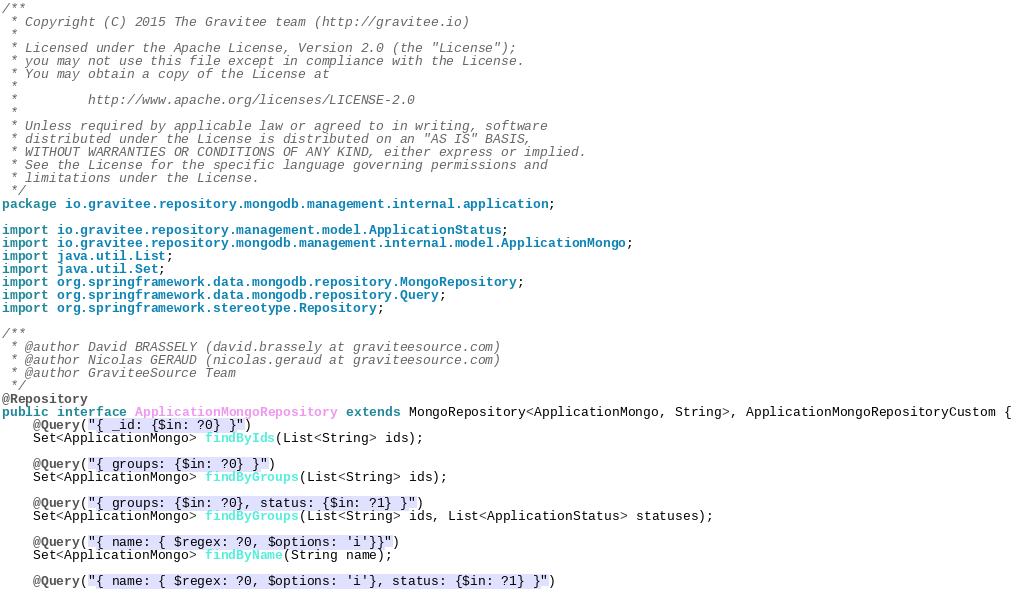Convert code to text. <code><loc_0><loc_0><loc_500><loc_500><_Java_>/**
 * Copyright (C) 2015 The Gravitee team (http://gravitee.io)
 *
 * Licensed under the Apache License, Version 2.0 (the "License");
 * you may not use this file except in compliance with the License.
 * You may obtain a copy of the License at
 *
 *         http://www.apache.org/licenses/LICENSE-2.0
 *
 * Unless required by applicable law or agreed to in writing, software
 * distributed under the License is distributed on an "AS IS" BASIS,
 * WITHOUT WARRANTIES OR CONDITIONS OF ANY KIND, either express or implied.
 * See the License for the specific language governing permissions and
 * limitations under the License.
 */
package io.gravitee.repository.mongodb.management.internal.application;

import io.gravitee.repository.management.model.ApplicationStatus;
import io.gravitee.repository.mongodb.management.internal.model.ApplicationMongo;
import java.util.List;
import java.util.Set;
import org.springframework.data.mongodb.repository.MongoRepository;
import org.springframework.data.mongodb.repository.Query;
import org.springframework.stereotype.Repository;

/**
 * @author David BRASSELY (david.brassely at graviteesource.com)
 * @author Nicolas GERAUD (nicolas.geraud at graviteesource.com)
 * @author GraviteeSource Team
 */
@Repository
public interface ApplicationMongoRepository extends MongoRepository<ApplicationMongo, String>, ApplicationMongoRepositoryCustom {
    @Query("{ _id: {$in: ?0} }")
    Set<ApplicationMongo> findByIds(List<String> ids);

    @Query("{ groups: {$in: ?0} }")
    Set<ApplicationMongo> findByGroups(List<String> ids);

    @Query("{ groups: {$in: ?0}, status: {$in: ?1} }")
    Set<ApplicationMongo> findByGroups(List<String> ids, List<ApplicationStatus> statuses);

    @Query("{ name: { $regex: ?0, $options: 'i'}}")
    Set<ApplicationMongo> findByName(String name);

    @Query("{ name: { $regex: ?0, $options: 'i'}, status: {$in: ?1} }")</code> 